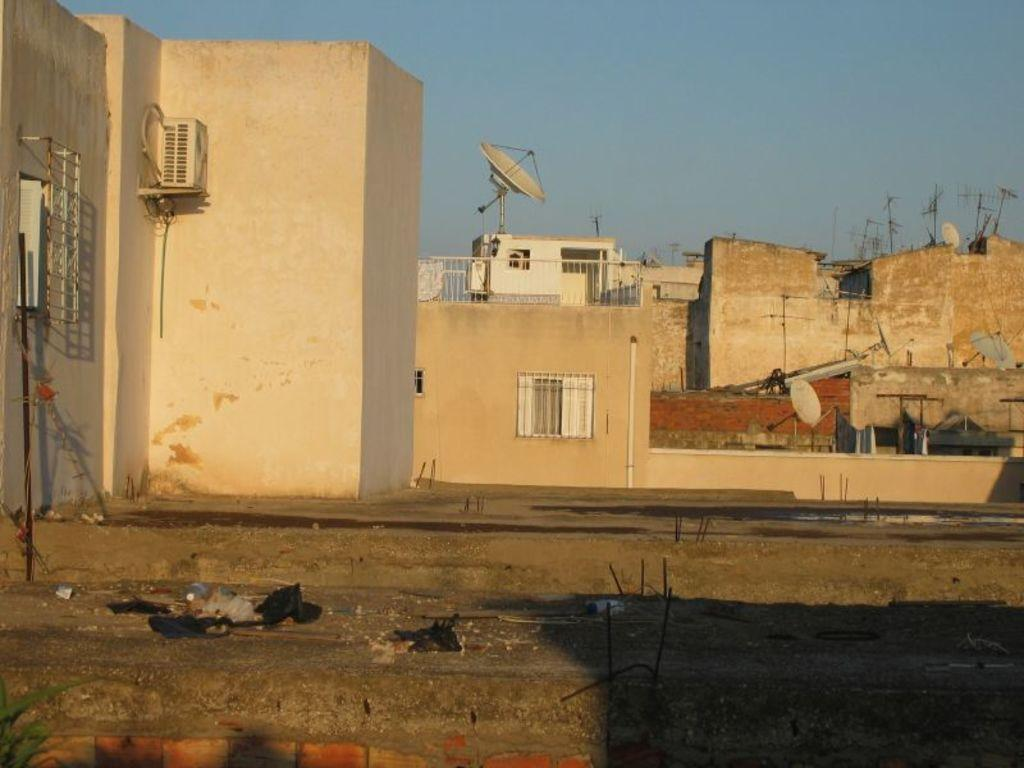What type of structures are present in the image? There are buildings in the image. What can be seen in the background of the image? There are satellite dishes and antennas in the background. What is visible at the top of the image? The sky is visible at the top of the image. What might be used for safety or support in the image? There is railing in the middle of the image. Can you see the roots of the trees in the image? There are no trees present in the image, so there are no roots to be seen. 